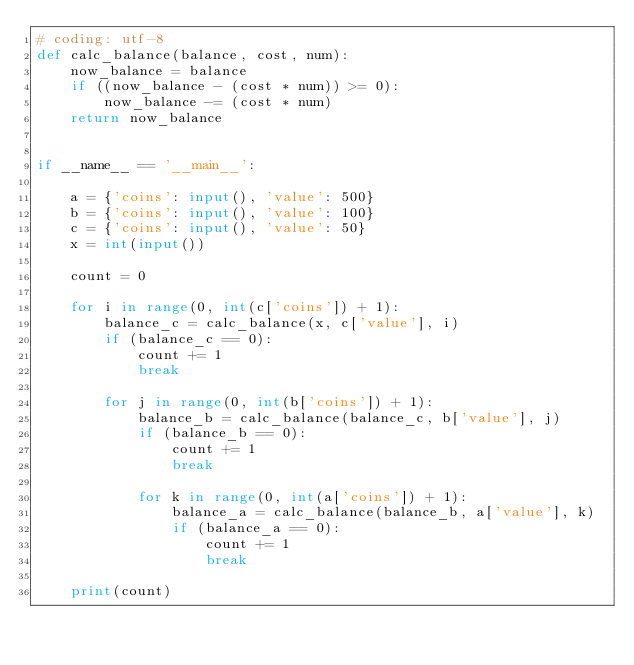Convert code to text. <code><loc_0><loc_0><loc_500><loc_500><_Python_># coding: utf-8
def calc_balance(balance, cost, num):
    now_balance = balance
    if ((now_balance - (cost * num)) >= 0):
        now_balance -= (cost * num)
    return now_balance


if __name__ == '__main__':

    a = {'coins': input(), 'value': 500}
    b = {'coins': input(), 'value': 100}
    c = {'coins': input(), 'value': 50}
    x = int(input())

    count = 0

    for i in range(0, int(c['coins']) + 1):
        balance_c = calc_balance(x, c['value'], i)
        if (balance_c == 0):
            count += 1
            break

        for j in range(0, int(b['coins']) + 1):
            balance_b = calc_balance(balance_c, b['value'], j)
            if (balance_b == 0):
                count += 1
                break

            for k in range(0, int(a['coins']) + 1):
                balance_a = calc_balance(balance_b, a['value'], k)
                if (balance_a == 0):
                    count += 1
                    break

    print(count)</code> 